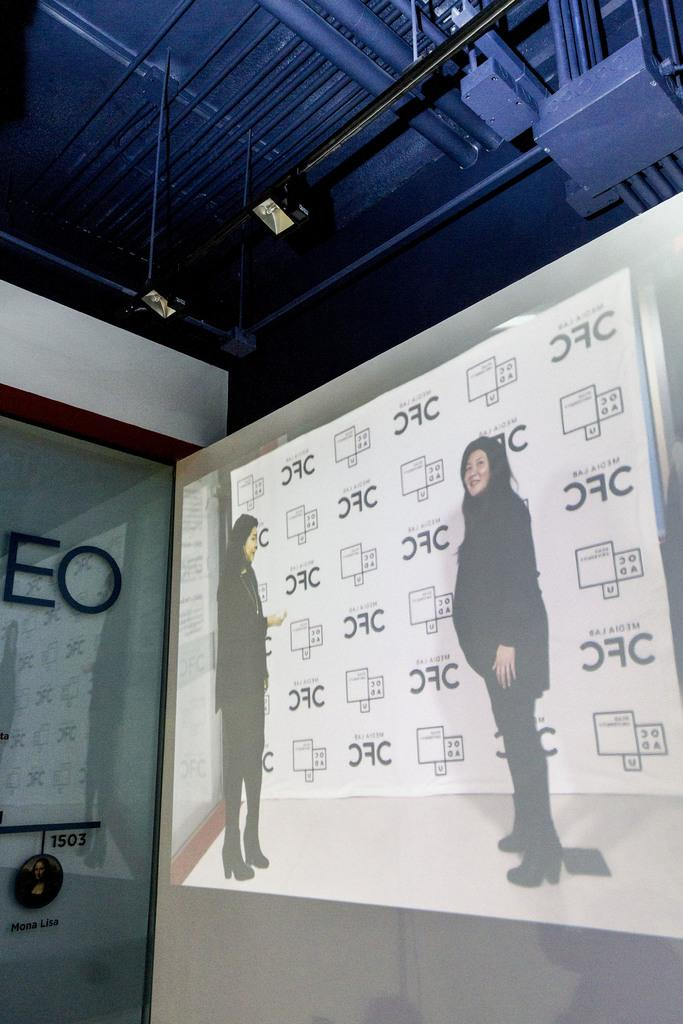How many people are in the image? There are two women standing in the image. What can be seen in the image besides the women? There are lights and a shed visible in the image. Are the women in the image giants? No, the women in the image are not giants; they appear to be of normal size. 